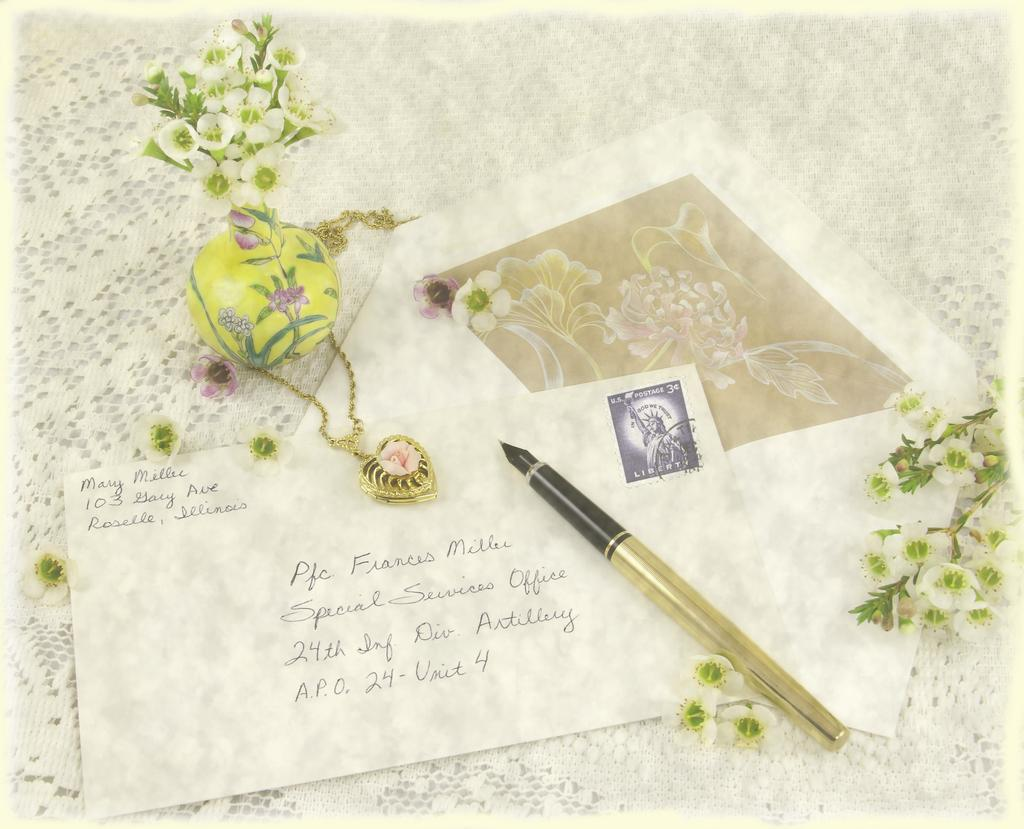<image>
Describe the image concisely. some has written a letter to Frances who is in unit 4 